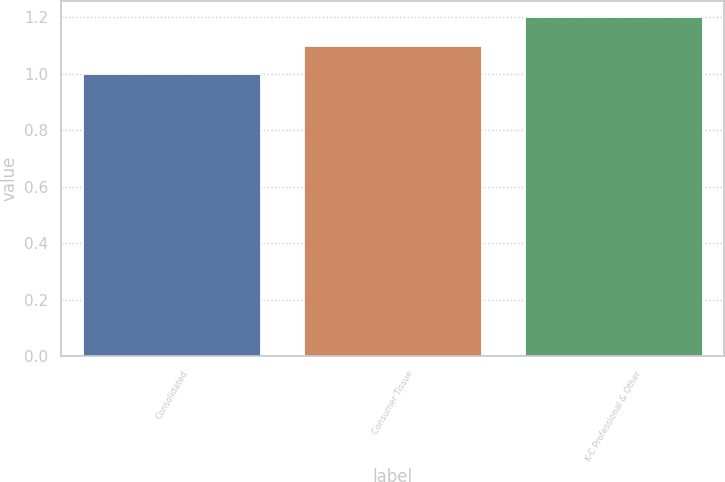Convert chart to OTSL. <chart><loc_0><loc_0><loc_500><loc_500><bar_chart><fcel>Consolidated<fcel>Consumer Tissue<fcel>K-C Professional & Other<nl><fcel>1<fcel>1.1<fcel>1.2<nl></chart> 